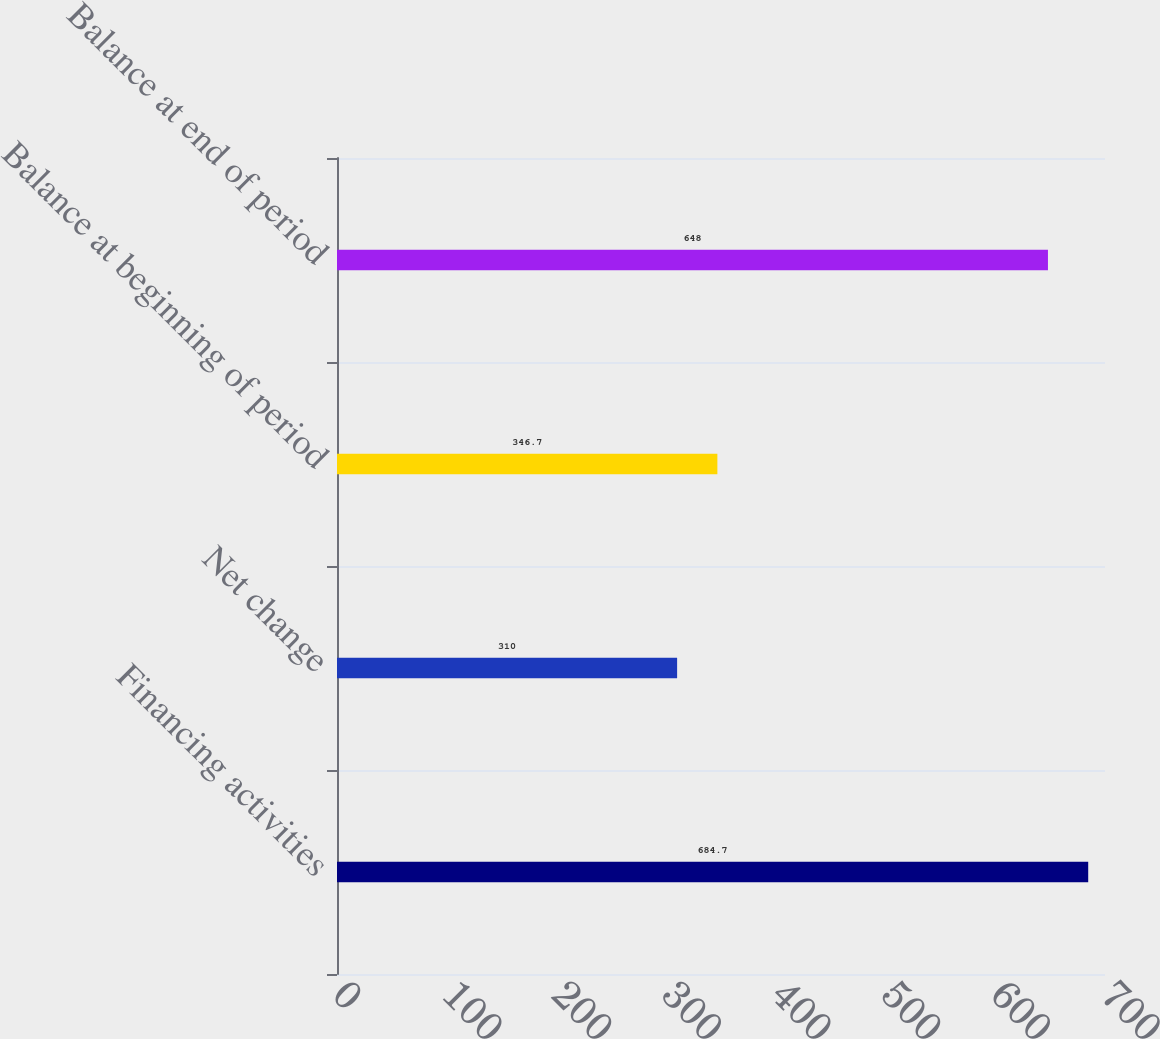<chart> <loc_0><loc_0><loc_500><loc_500><bar_chart><fcel>Financing activities<fcel>Net change<fcel>Balance at beginning of period<fcel>Balance at end of period<nl><fcel>684.7<fcel>310<fcel>346.7<fcel>648<nl></chart> 